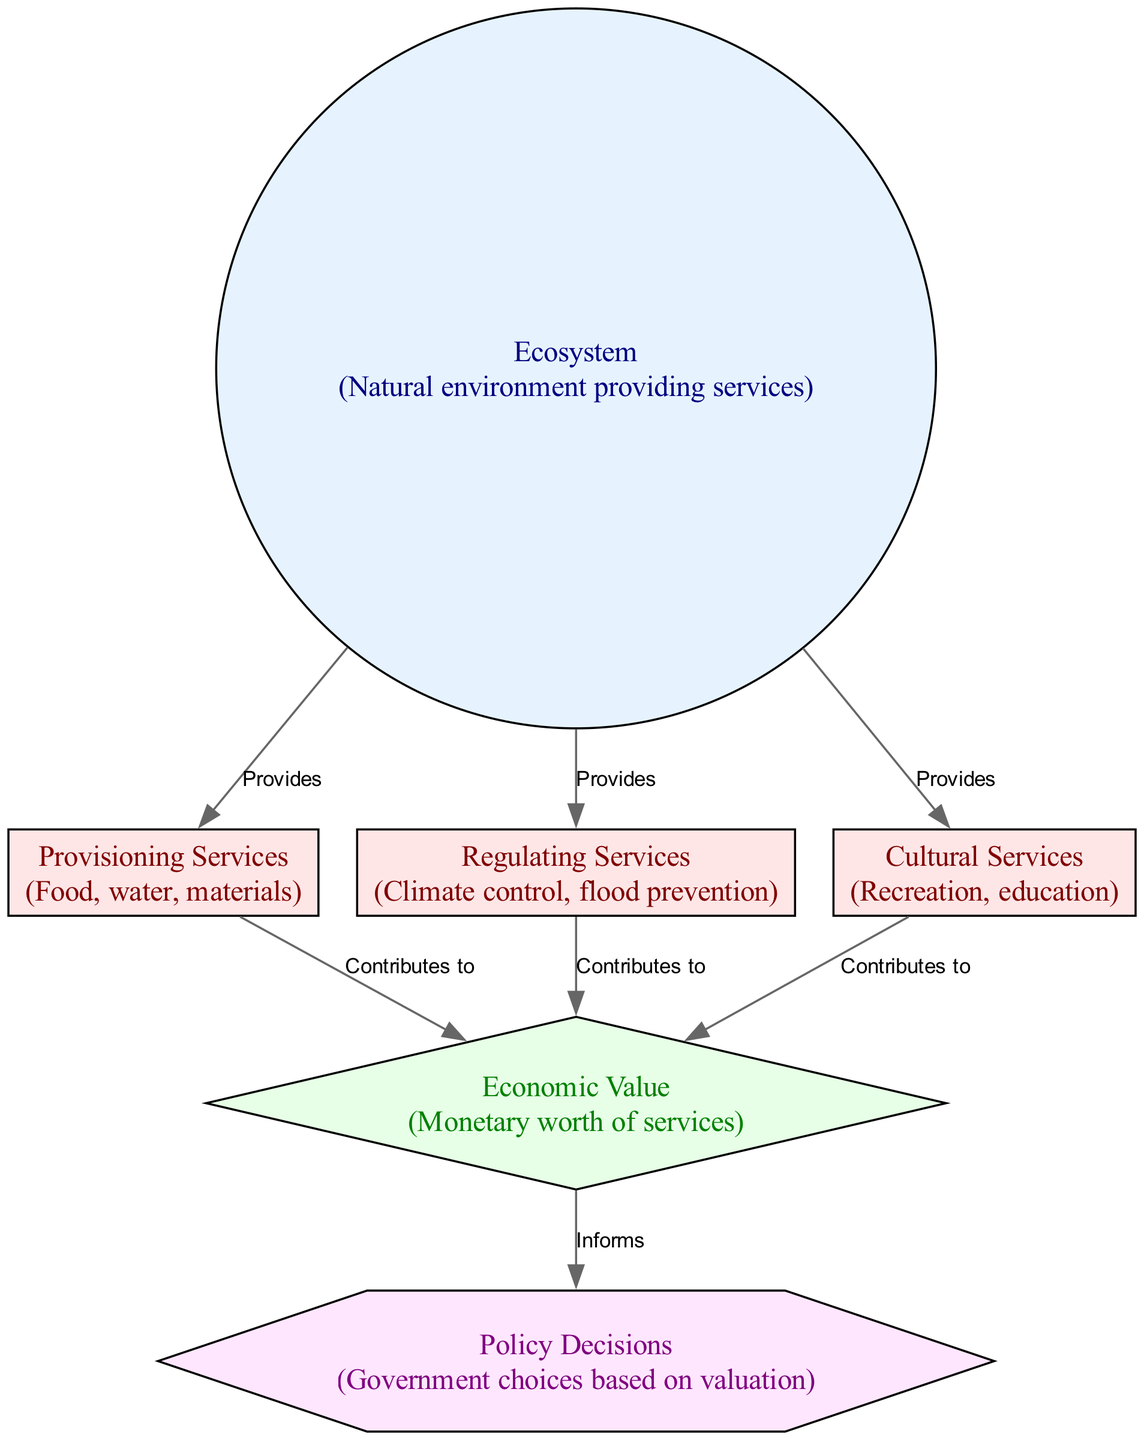What are the three types of services provided by the ecosystem? The diagram lists three types of services: Provisioning Services, Regulating Services, and Cultural Services. These nodes stem directly from the Ecosystem node, indicating that these are the primary services the ecosystem offers.
Answer: Provisioning Services, Regulating Services, Cultural Services How many nodes are there in the diagram? The diagram contains six nodes in total: Ecosystem, Provisioning Services, Regulating Services, Cultural Services, Economic Value, and Policy Decisions. These can be counted directly from the node section of the diagram.
Answer: 6 What does Provisioning Services contribute to? Provisioning Services contributes to Economic Value, as shown by the directed edge leading from Provisioning Services to Economic Value with the label "Contributes to." This illustrates that the provision of food, water, and materials has an economic worth.
Answer: Economic Value In what way does Economic Value inform Policy Decisions? Economic Value informs Policy Decisions as indicated by the directed edge from Economic Value to Policy Decisions labeled "Informs." This means that the monetary worth derived from ecosystem services ultimately aids the government in making informed choices regarding policies.
Answer: Informs Which service is connected to climate control? The Regulating Services node is connected to climate control, as it directly represents services that manage environmental conditions like climate and flood prevention.  Its description in the diagram confirms its role in regulating climate.
Answer: Regulating Services 